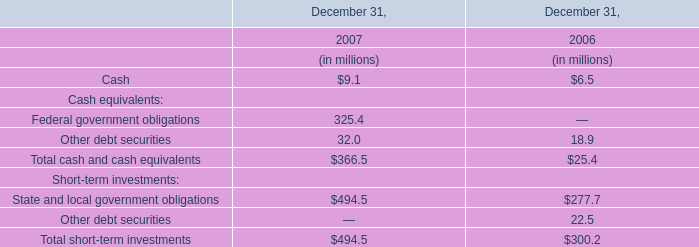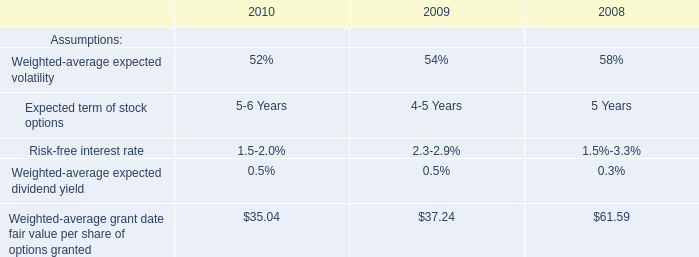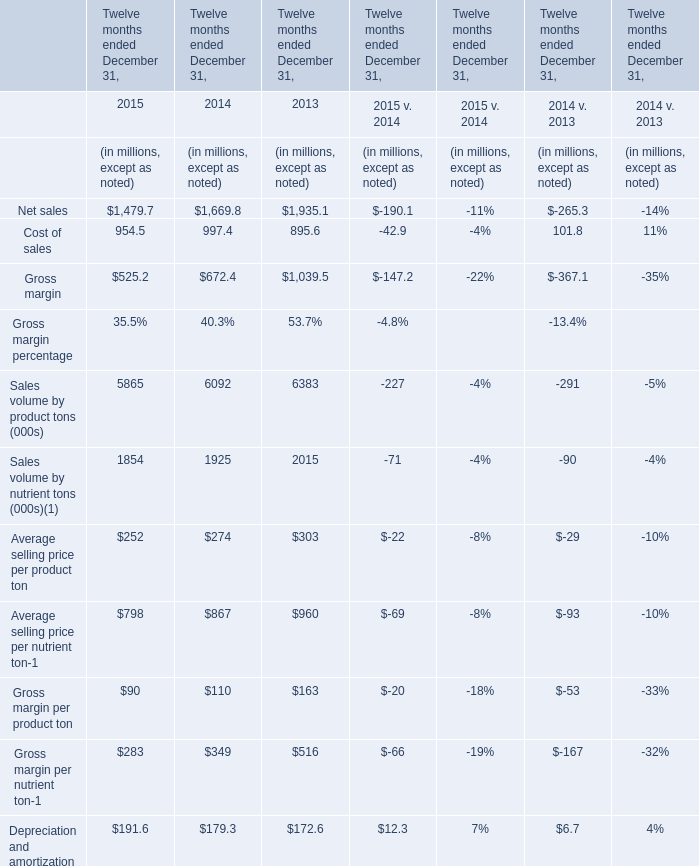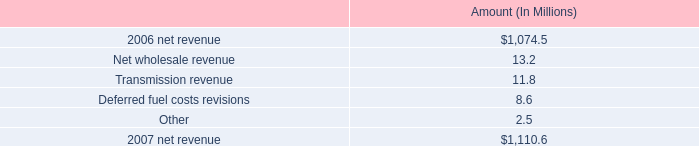What is the sum of Gross margin in 2014 and Total cash and cash equivalents in 2007? (in million) 
Computations: (672.4 + 366.5)
Answer: 1038.9. 